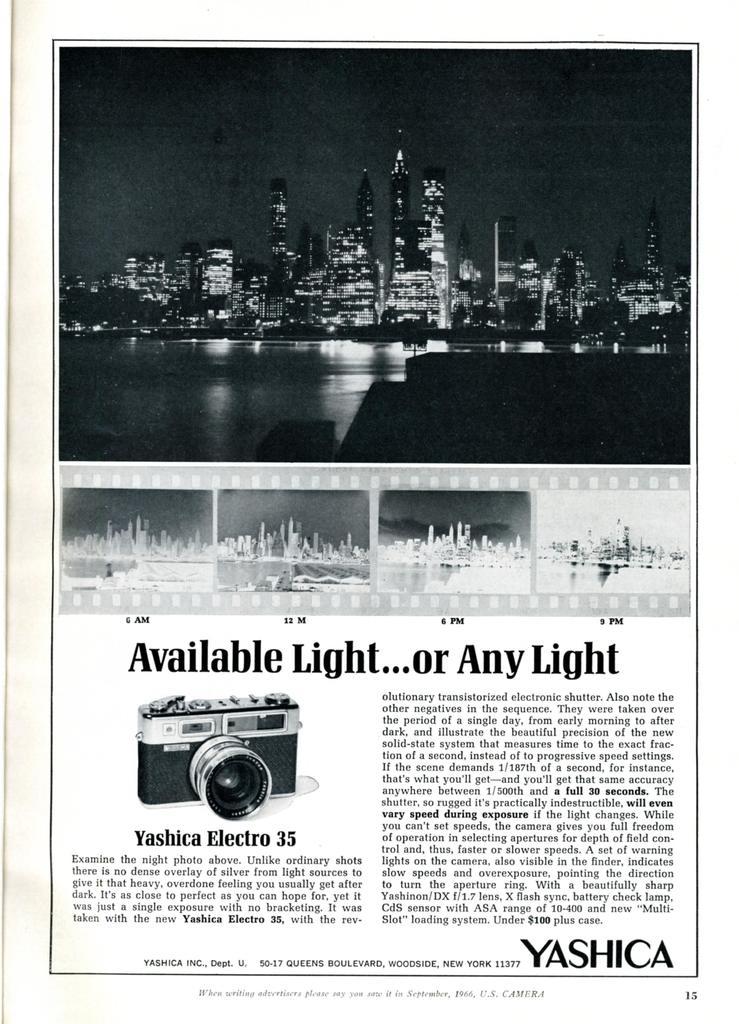What light is mentioned in the article?
Your answer should be compact. Available light. What is the camera brand called?
Your answer should be very brief. Yashica. 